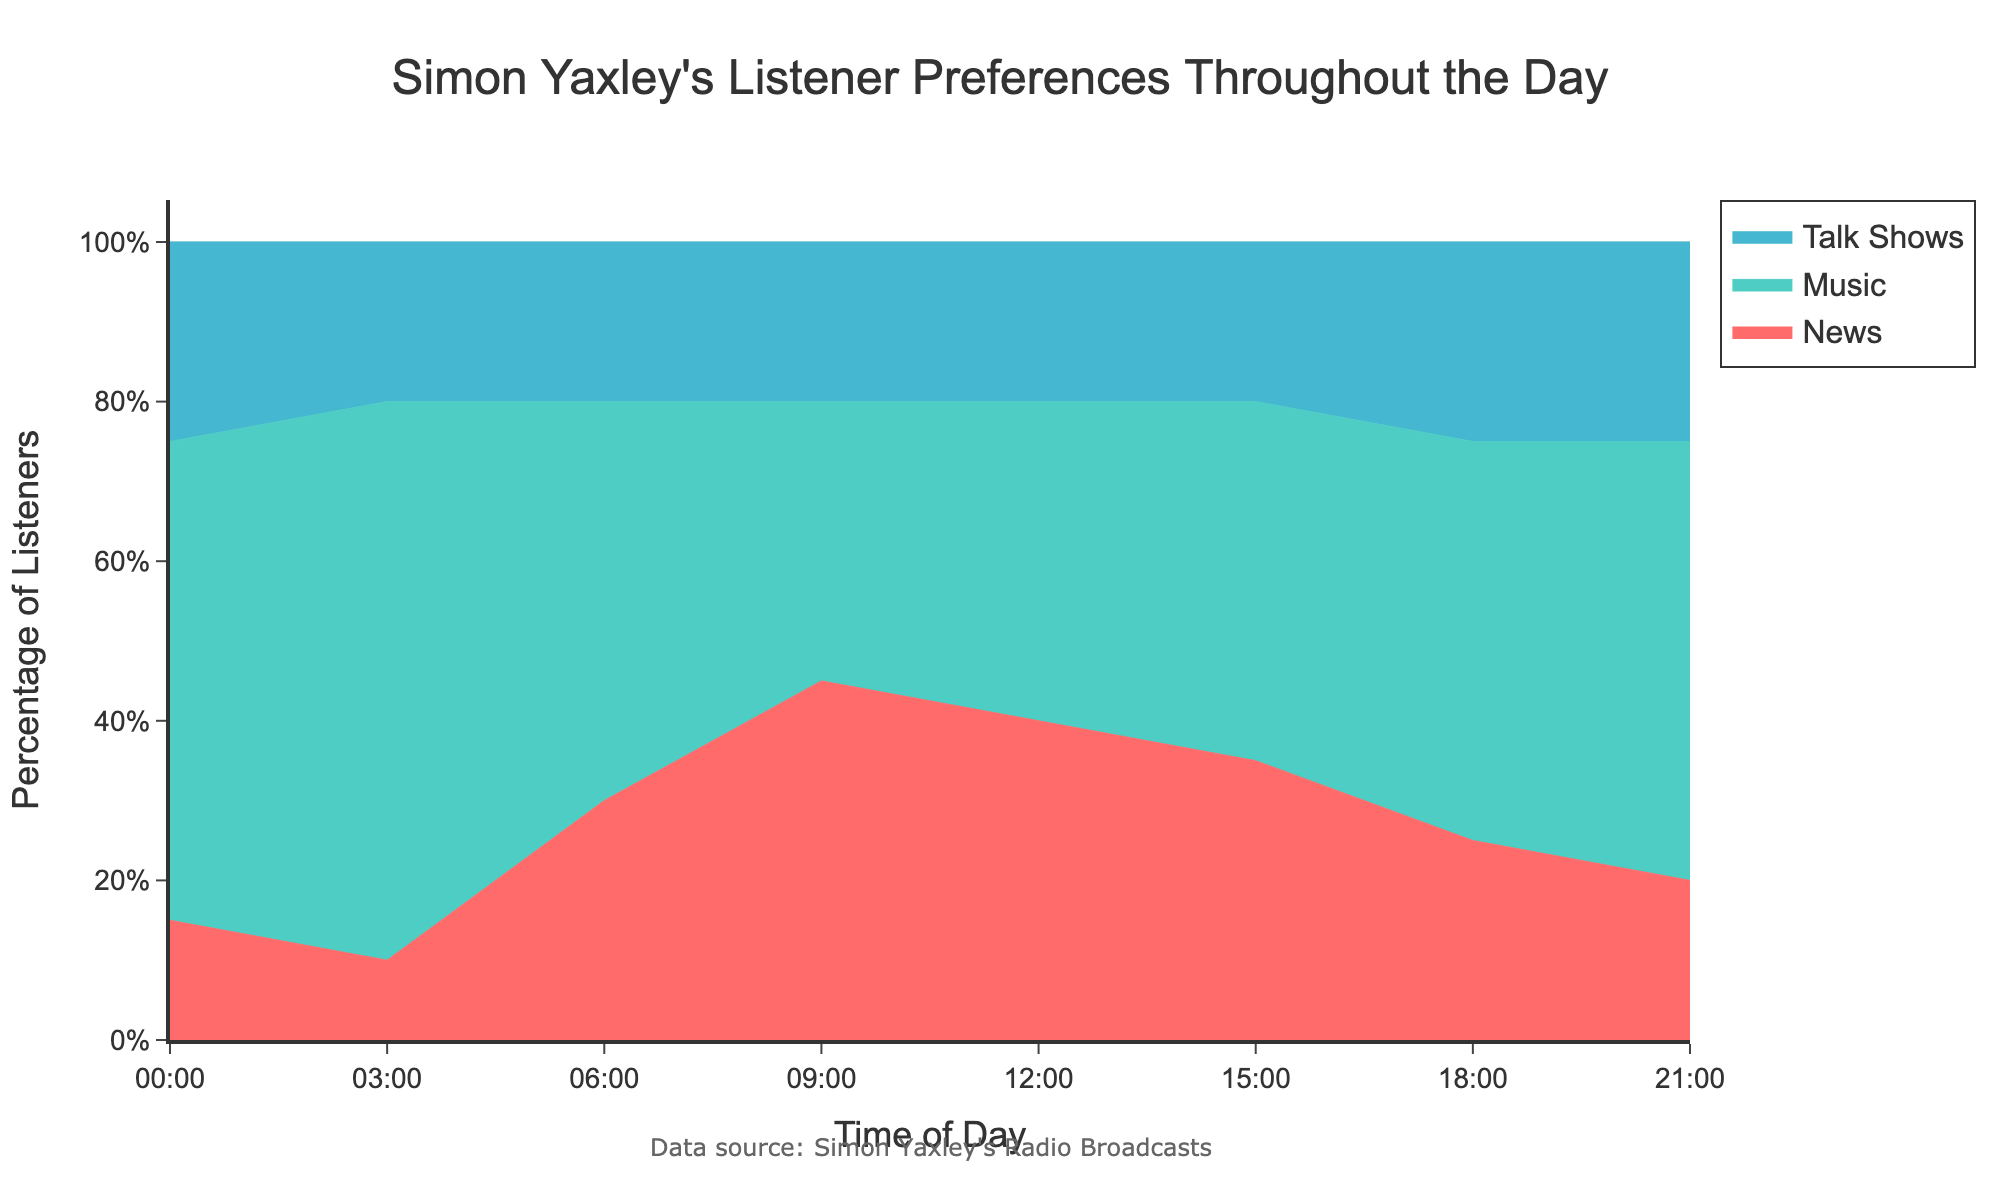what is the title of the chart? The title of the chart is typically placed at the top of the chart and specifies the subject of the data being visualized. In this case, it reads "Simon Yaxley's Listener Preferences Throughout the Day".
Answer: Simon Yaxley's Listener Preferences Throughout the Day During which time period is the percentage of News listeners the highest? To find when the percentage of News listeners is highest, examine the 100% Stacked Area Chart and look for the time interval where the News area is the largest. From the chart, we notice that the highest percentage is at 09:00.
Answer: 09:00 At 03:00, what is the percentage breakdown of listener preferences for each category? At 03:00, the chart shows the distribution of listeners. The percentages are directly visualized as areas on the 100% Stacked Area Chart. Refer to the height of each segment at 03:00: News (10%), Music (70%), Talk Shows (20%).
Answer: News: 10%, Music: 70%, Talk Shows: 20% How does the percentage of Music listeners change from 00:00 to 21:00? To determine the change, observe the Music section of the Stacked Area Chart across the given times. Initially (00:00), Music is at 60%, and it ends (21:00) at 55%. Therefore, it slightly decreases over the period.
Answer: Decreases slightly Which type of content sees a consistent percentage throughout the day? To identify this, examine the trends of each category in the chart. The segment that maintains a consistent height or shows little fluctuation is Talk Shows, which remains around 20-25% throughout the day.
Answer: Talk Shows Between 06:00 and 12:00, which content group sees the most significant decrease in listener percentage? Examine the changes in segment sizes between 06:00 and 12:00 for each category. News shrinks from 30% to 40%, Music remains stable, so the most noticeable decrease is in News.
Answer: News What is the overall trend for News listeners throughout the day? Track the size of the News section from 00:00 to 21:00. News starts with 15%, increases to a peak at 09:00 (45%), and then gradually decreases to end at 20%.
Answer: Increases then decreases Compare the preference for Talk Shows at 06:00 and 18:00. Which time has a higher percentage? Look at the percentage heights for Talk Shows at the given times. Both times show Talk Shows at 20% initially and then at 25%, so 18:00 has a higher preference.
Answer: 18:00 What percentage of listeners prefer Music at 15:00? To determine the percentage preference for Music at 15:00, refer to the chart where the height of the Music area at that time is represented. The percentage is 45%.
Answer: 45% What can you infer about listener preferences during early mornings (00:00) compared to late evenings (21:00)? Compare the distribution segments at 00:00 and at 21:00 for each category. Music remains relatively stable, News sees a decline from 15% to 20%, while Talk Shows increase from 25% to 25%.
Answer: Music stable, News decreases, Talk Shows increases 